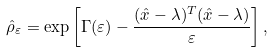<formula> <loc_0><loc_0><loc_500><loc_500>\hat { \rho } _ { \varepsilon } = \exp \left [ \Gamma ( \varepsilon ) - \frac { ( \hat { x } - \lambda ) ^ { T } ( \hat { x } - \lambda ) } { \varepsilon } \right ] ,</formula> 